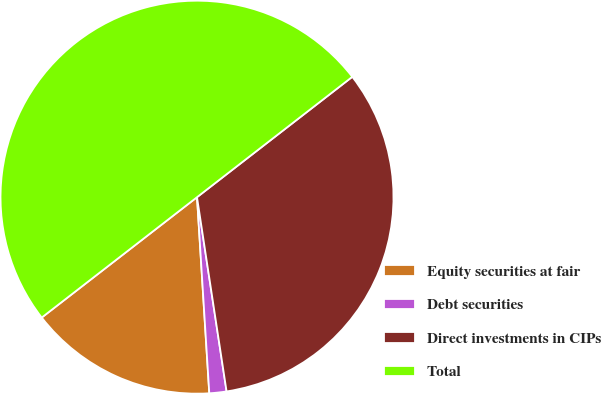<chart> <loc_0><loc_0><loc_500><loc_500><pie_chart><fcel>Equity securities at fair<fcel>Debt securities<fcel>Direct investments in CIPs<fcel>Total<nl><fcel>15.5%<fcel>1.41%<fcel>33.09%<fcel>50.0%<nl></chart> 